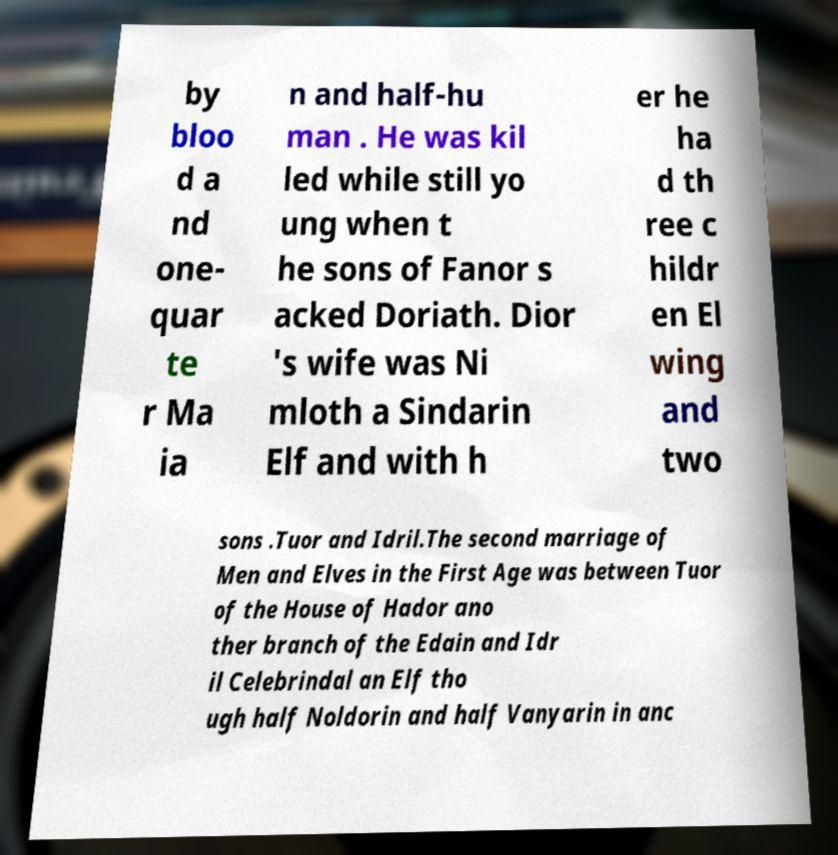Could you extract and type out the text from this image? by bloo d a nd one- quar te r Ma ia n and half-hu man . He was kil led while still yo ung when t he sons of Fanor s acked Doriath. Dior 's wife was Ni mloth a Sindarin Elf and with h er he ha d th ree c hildr en El wing and two sons .Tuor and Idril.The second marriage of Men and Elves in the First Age was between Tuor of the House of Hador ano ther branch of the Edain and Idr il Celebrindal an Elf tho ugh half Noldorin and half Vanyarin in anc 